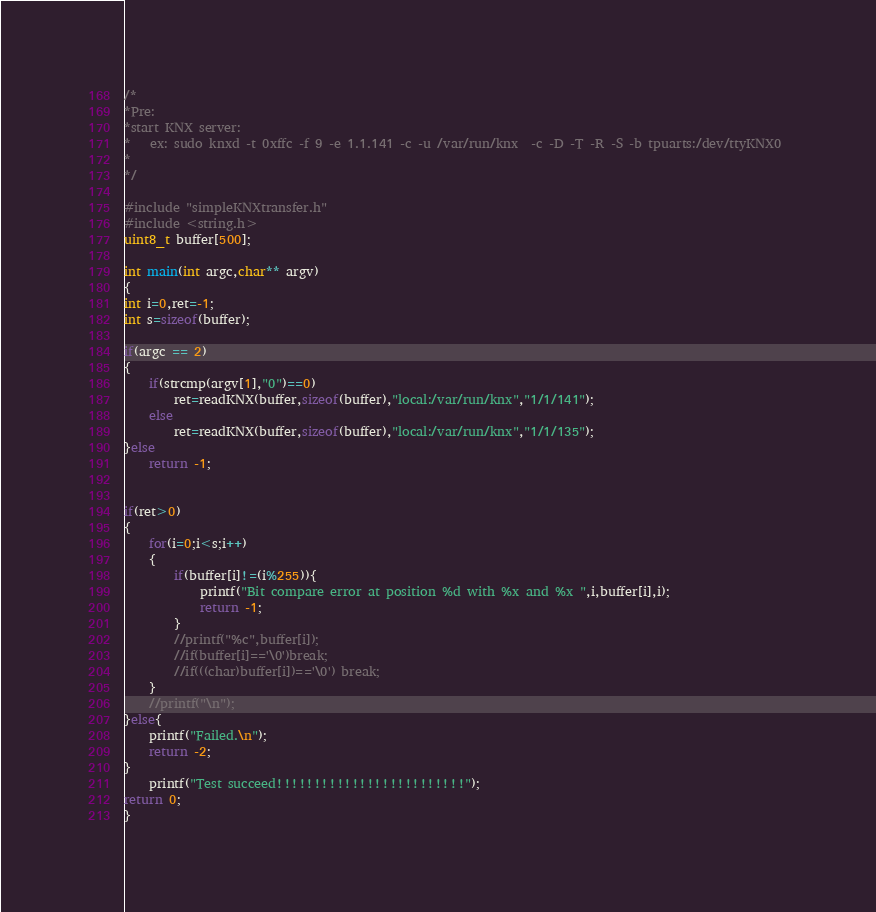Convert code to text. <code><loc_0><loc_0><loc_500><loc_500><_C_>/*
*Pre:
*start KNX server:
*	ex: sudo knxd -t 0xffc -f 9 -e 1.1.141 -c -u /var/run/knx  -c -D -T -R -S -b tpuarts:/dev/ttyKNX0 
*
*/

#include "simpleKNXtransfer.h"
#include <string.h>
uint8_t buffer[500];

int main(int argc,char** argv)
{
int i=0,ret=-1;
int s=sizeof(buffer);

if(argc == 2)
{
	if(strcmp(argv[1],"0")==0)
		ret=readKNX(buffer,sizeof(buffer),"local:/var/run/knx","1/1/141");
	else
		ret=readKNX(buffer,sizeof(buffer),"local:/var/run/knx","1/1/135");
}else
	return -1;


if(ret>0)
{	
	for(i=0;i<s;i++)
	{
		if(buffer[i]!=(i%255)){
			printf("Bit compare error at position %d with %x and %x ",i,buffer[i],i);
			return -1;
		}
		//printf("%c",buffer[i]);
		//if(buffer[i]=='\0')break;
		//if(((char)buffer[i])=='\0') break;
	}
	//printf("\n");
}else{
	printf("Failed.\n");
	return -2; 
}
	printf("Test succeed!!!!!!!!!!!!!!!!!!!!!!!!!");
return 0;
}
</code> 